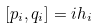<formula> <loc_0><loc_0><loc_500><loc_500>[ p _ { i } , q _ { i } ] = { i } h _ { i }</formula> 